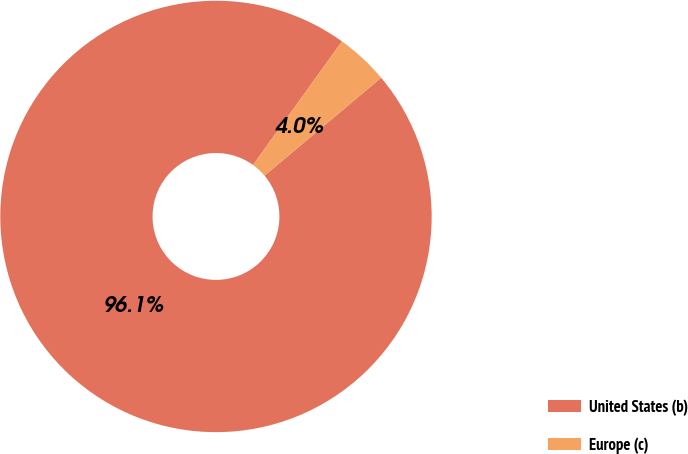<chart> <loc_0><loc_0><loc_500><loc_500><pie_chart><fcel>United States (b)<fcel>Europe (c)<nl><fcel>96.05%<fcel>3.95%<nl></chart> 